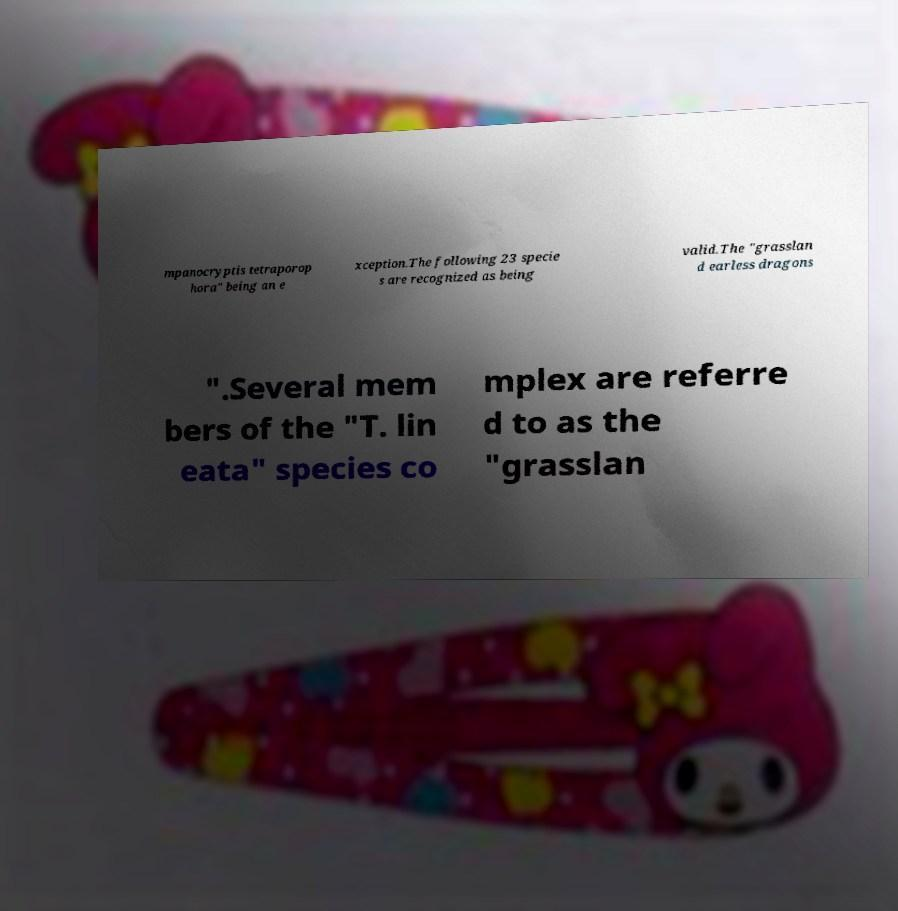Can you accurately transcribe the text from the provided image for me? mpanocryptis tetraporop hora" being an e xception.The following 23 specie s are recognized as being valid.The "grasslan d earless dragons ".Several mem bers of the "T. lin eata" species co mplex are referre d to as the "grasslan 